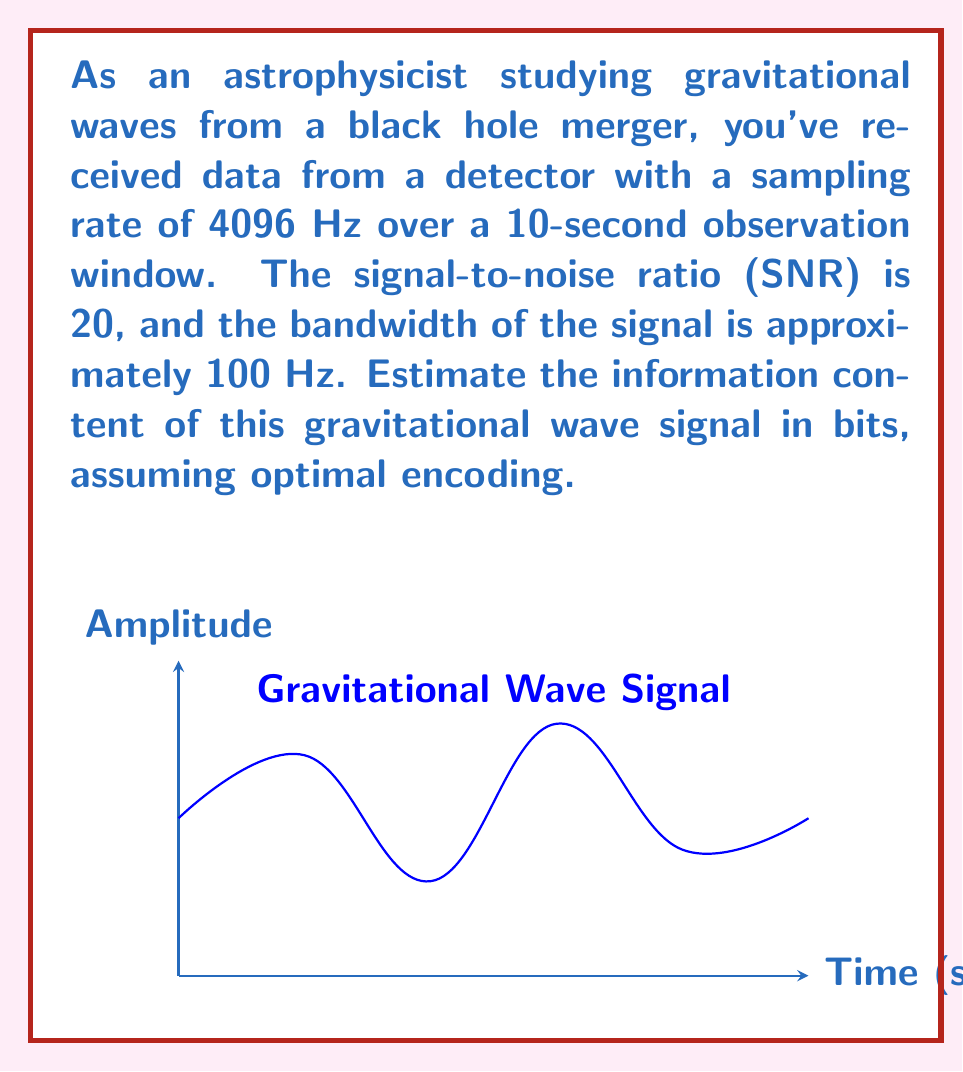Help me with this question. Let's approach this step-by-step using the principles of information theory:

1) First, we need to calculate the number of independent samples. Given the sampling rate and observation window:
   $N = \text{Sampling Rate} \times \text{Observation Time} = 4096 \text{ Hz} \times 10 \text{ s} = 40960$

2) The bandwidth of the signal is 100 Hz, which is less than the Nyquist frequency (2048 Hz). This means we can use the bandwidth-limited formula for information content.

3) The formula for the information content of a bandwidth-limited signal is:
   $$I = 2BT \log_2(1 + \text{SNR})$$
   Where $B$ is the bandwidth, $T$ is the observation time, and SNR is the signal-to-noise ratio.

4) Substituting our values:
   $$I = 2 \times 100 \text{ Hz} \times 10 \text{ s} \times \log_2(1 + 20)$$

5) Simplify:
   $$I = 2000 \times \log_2(21)$$

6) Calculate:
   $$I = 2000 \times 4.3923 = 8784.6 \text{ bits}$$

7) Rounding to the nearest whole number:
   $$I \approx 8785 \text{ bits}$$

This result represents the theoretical maximum amount of information that could be extracted from this gravitational wave signal, assuming optimal encoding.
Answer: 8785 bits 